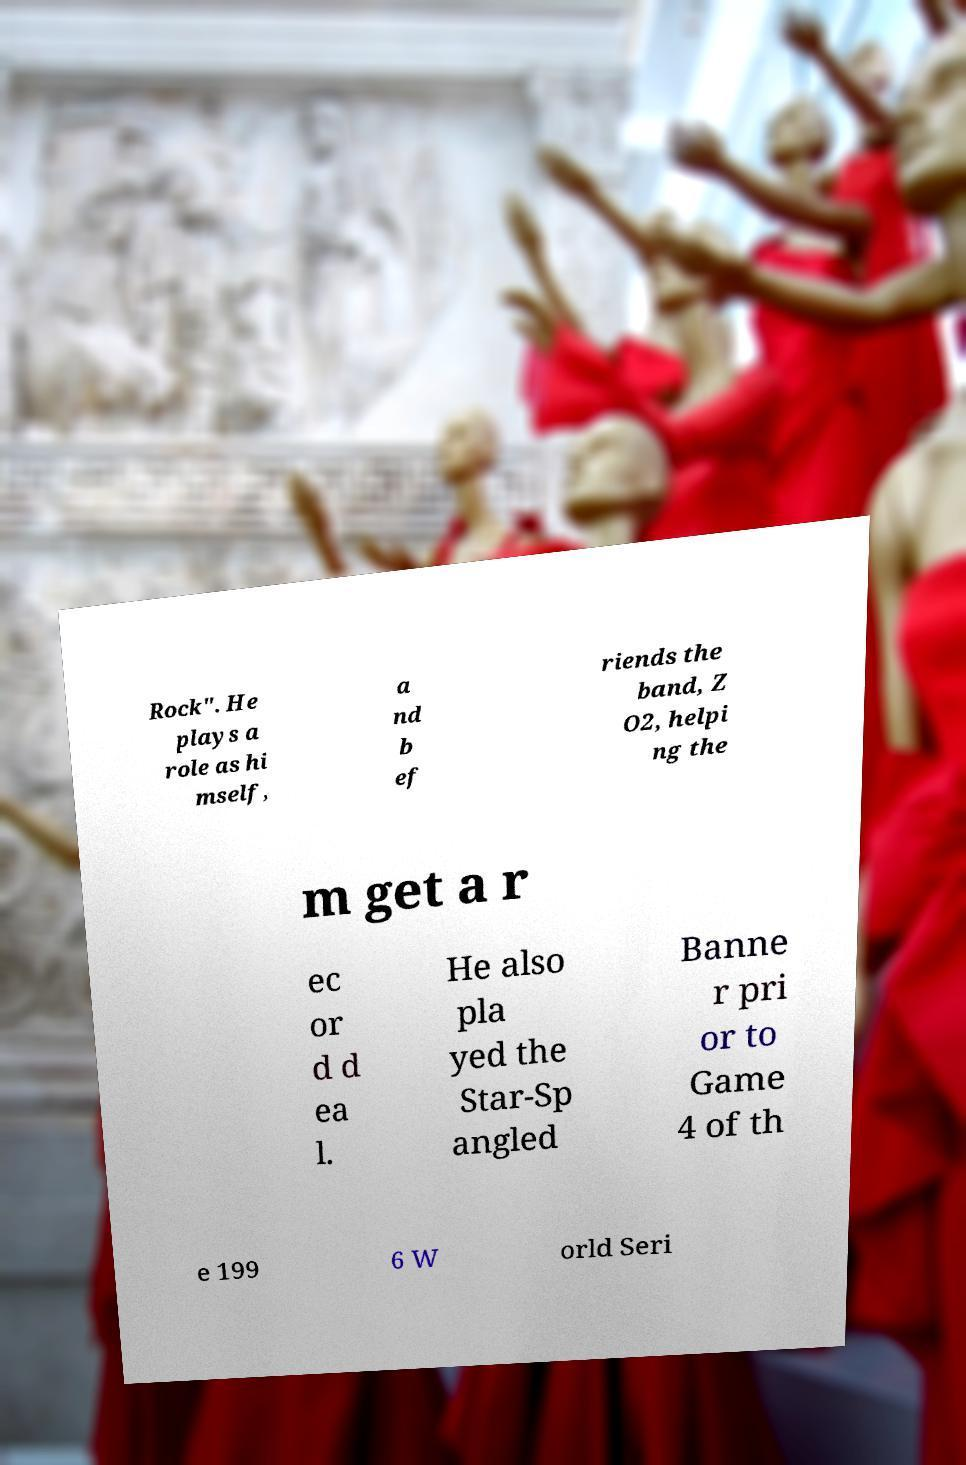Could you assist in decoding the text presented in this image and type it out clearly? Rock". He plays a role as hi mself, a nd b ef riends the band, Z O2, helpi ng the m get a r ec or d d ea l. He also pla yed the Star-Sp angled Banne r pri or to Game 4 of th e 199 6 W orld Seri 